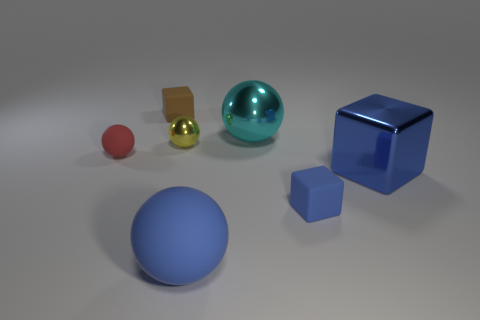The ball that is both right of the small yellow metal sphere and behind the tiny matte sphere is what color?
Ensure brevity in your answer.  Cyan. The big matte object that is the same color as the large metal block is what shape?
Your response must be concise. Sphere. What size is the matte ball that is on the right side of the brown thing that is left of the yellow metallic sphere?
Your response must be concise. Large. What number of cylinders are either red rubber objects or small brown matte objects?
Offer a very short reply. 0. What color is the rubber ball that is the same size as the yellow shiny object?
Keep it short and to the point. Red. There is a tiny shiny object on the left side of the big cyan shiny object behind the tiny yellow thing; what shape is it?
Keep it short and to the point. Sphere. There is a rubber cube that is to the right of the yellow metal thing; does it have the same size as the tiny yellow thing?
Give a very brief answer. Yes. How many other objects are there of the same material as the tiny red object?
Provide a succinct answer. 3. How many purple objects are tiny rubber things or big things?
Keep it short and to the point. 0. What size is the other matte thing that is the same color as the large rubber thing?
Provide a succinct answer. Small. 